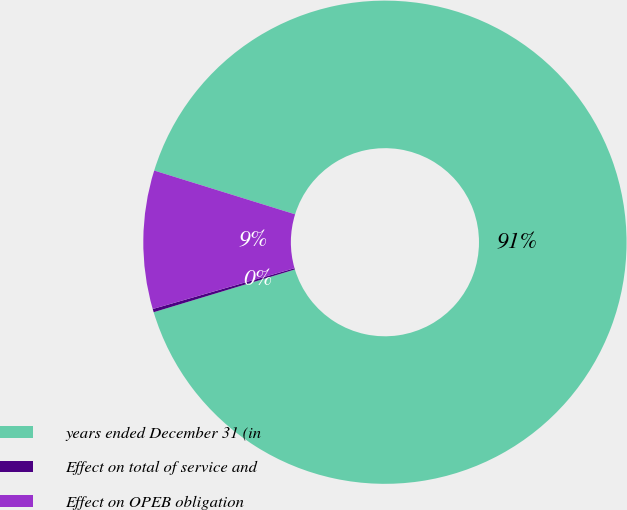Convert chart to OTSL. <chart><loc_0><loc_0><loc_500><loc_500><pie_chart><fcel>years ended December 31 (in<fcel>Effect on total of service and<fcel>Effect on OPEB obligation<nl><fcel>90.52%<fcel>0.22%<fcel>9.25%<nl></chart> 